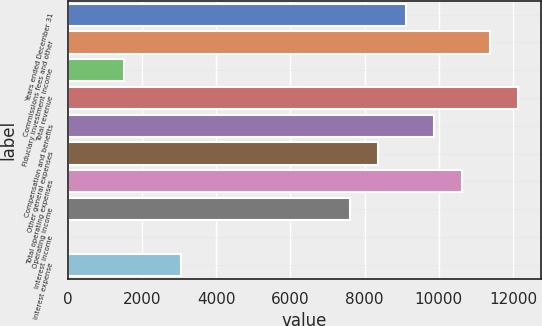Convert chart to OTSL. <chart><loc_0><loc_0><loc_500><loc_500><bar_chart><fcel>Years ended December 31<fcel>Commissions fees and other<fcel>Fiduciary investment income<fcel>Total revenue<fcel>Compensation and benefits<fcel>Other general expenses<fcel>Total operating expenses<fcel>Operating income<fcel>Interest income<fcel>Interest expense<nl><fcel>9110.8<fcel>11384.5<fcel>1531.8<fcel>12142.4<fcel>9868.7<fcel>8352.9<fcel>10626.6<fcel>7595<fcel>16<fcel>3047.6<nl></chart> 